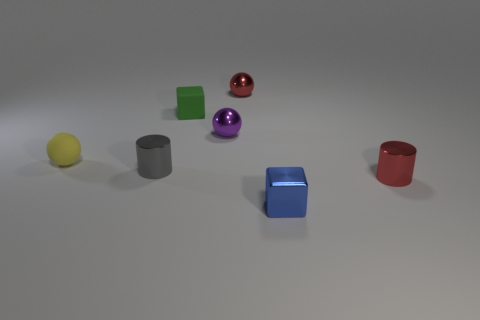There is a tiny cylinder that is to the right of the small red sphere; is its color the same as the block that is in front of the tiny yellow thing?
Your answer should be very brief. No. Are there more tiny gray things behind the small yellow matte sphere than purple balls?
Your answer should be compact. No. There is a red object behind the green matte thing; does it have the same size as the green rubber object?
Make the answer very short. Yes. Are there any blue shiny blocks of the same size as the green matte thing?
Provide a short and direct response. Yes. There is a metal ball behind the tiny purple shiny ball; what is its color?
Provide a short and direct response. Red. The small object that is both in front of the yellow matte object and left of the small green thing has what shape?
Keep it short and to the point. Cylinder. What number of tiny yellow rubber things are the same shape as the small blue object?
Your answer should be very brief. 0. How many tiny yellow metallic things are there?
Ensure brevity in your answer.  0. What is the size of the object that is both on the left side of the small green object and behind the gray cylinder?
Your answer should be very brief. Small. What is the shape of the blue metallic object that is the same size as the matte block?
Provide a succinct answer. Cube. 